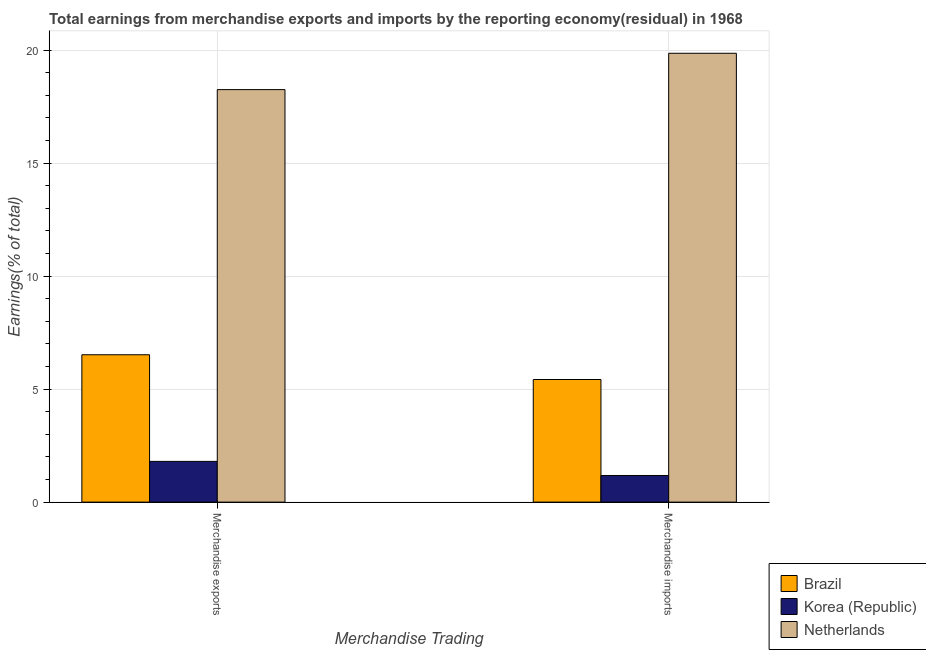Are the number of bars on each tick of the X-axis equal?
Provide a succinct answer. Yes. How many bars are there on the 2nd tick from the left?
Provide a short and direct response. 3. How many bars are there on the 1st tick from the right?
Keep it short and to the point. 3. What is the earnings from merchandise exports in Brazil?
Give a very brief answer. 6.52. Across all countries, what is the maximum earnings from merchandise imports?
Make the answer very short. 19.86. Across all countries, what is the minimum earnings from merchandise imports?
Provide a short and direct response. 1.18. In which country was the earnings from merchandise exports maximum?
Your answer should be compact. Netherlands. In which country was the earnings from merchandise exports minimum?
Give a very brief answer. Korea (Republic). What is the total earnings from merchandise exports in the graph?
Give a very brief answer. 26.58. What is the difference between the earnings from merchandise exports in Korea (Republic) and that in Brazil?
Your response must be concise. -4.72. What is the difference between the earnings from merchandise imports in Netherlands and the earnings from merchandise exports in Korea (Republic)?
Keep it short and to the point. 18.06. What is the average earnings from merchandise imports per country?
Keep it short and to the point. 8.82. What is the difference between the earnings from merchandise imports and earnings from merchandise exports in Korea (Republic)?
Offer a very short reply. -0.62. In how many countries, is the earnings from merchandise imports greater than 11 %?
Your response must be concise. 1. What is the ratio of the earnings from merchandise exports in Brazil to that in Korea (Republic)?
Keep it short and to the point. 3.62. Is the earnings from merchandise imports in Netherlands less than that in Korea (Republic)?
Provide a succinct answer. No. In how many countries, is the earnings from merchandise exports greater than the average earnings from merchandise exports taken over all countries?
Offer a very short reply. 1. How many bars are there?
Make the answer very short. 6. How many countries are there in the graph?
Give a very brief answer. 3. What is the difference between two consecutive major ticks on the Y-axis?
Offer a terse response. 5. Are the values on the major ticks of Y-axis written in scientific E-notation?
Keep it short and to the point. No. Does the graph contain any zero values?
Ensure brevity in your answer.  No. Where does the legend appear in the graph?
Your answer should be compact. Bottom right. How many legend labels are there?
Provide a short and direct response. 3. How are the legend labels stacked?
Give a very brief answer. Vertical. What is the title of the graph?
Offer a terse response. Total earnings from merchandise exports and imports by the reporting economy(residual) in 1968. Does "Northern Mariana Islands" appear as one of the legend labels in the graph?
Your answer should be very brief. No. What is the label or title of the X-axis?
Provide a succinct answer. Merchandise Trading. What is the label or title of the Y-axis?
Make the answer very short. Earnings(% of total). What is the Earnings(% of total) of Brazil in Merchandise exports?
Offer a terse response. 6.52. What is the Earnings(% of total) in Korea (Republic) in Merchandise exports?
Provide a succinct answer. 1.8. What is the Earnings(% of total) of Netherlands in Merchandise exports?
Provide a succinct answer. 18.25. What is the Earnings(% of total) of Brazil in Merchandise imports?
Make the answer very short. 5.43. What is the Earnings(% of total) of Korea (Republic) in Merchandise imports?
Make the answer very short. 1.18. What is the Earnings(% of total) in Netherlands in Merchandise imports?
Provide a succinct answer. 19.86. Across all Merchandise Trading, what is the maximum Earnings(% of total) in Brazil?
Your response must be concise. 6.52. Across all Merchandise Trading, what is the maximum Earnings(% of total) of Korea (Republic)?
Give a very brief answer. 1.8. Across all Merchandise Trading, what is the maximum Earnings(% of total) of Netherlands?
Give a very brief answer. 19.86. Across all Merchandise Trading, what is the minimum Earnings(% of total) in Brazil?
Offer a terse response. 5.43. Across all Merchandise Trading, what is the minimum Earnings(% of total) of Korea (Republic)?
Your response must be concise. 1.18. Across all Merchandise Trading, what is the minimum Earnings(% of total) of Netherlands?
Provide a short and direct response. 18.25. What is the total Earnings(% of total) in Brazil in the graph?
Provide a succinct answer. 11.95. What is the total Earnings(% of total) of Korea (Republic) in the graph?
Your response must be concise. 2.98. What is the total Earnings(% of total) of Netherlands in the graph?
Your answer should be very brief. 38.12. What is the difference between the Earnings(% of total) in Brazil in Merchandise exports and that in Merchandise imports?
Provide a succinct answer. 1.09. What is the difference between the Earnings(% of total) of Korea (Republic) in Merchandise exports and that in Merchandise imports?
Provide a succinct answer. 0.62. What is the difference between the Earnings(% of total) of Netherlands in Merchandise exports and that in Merchandise imports?
Your answer should be compact. -1.61. What is the difference between the Earnings(% of total) of Brazil in Merchandise exports and the Earnings(% of total) of Korea (Republic) in Merchandise imports?
Keep it short and to the point. 5.34. What is the difference between the Earnings(% of total) in Brazil in Merchandise exports and the Earnings(% of total) in Netherlands in Merchandise imports?
Make the answer very short. -13.34. What is the difference between the Earnings(% of total) of Korea (Republic) in Merchandise exports and the Earnings(% of total) of Netherlands in Merchandise imports?
Provide a short and direct response. -18.06. What is the average Earnings(% of total) in Brazil per Merchandise Trading?
Provide a succinct answer. 5.97. What is the average Earnings(% of total) in Korea (Republic) per Merchandise Trading?
Ensure brevity in your answer.  1.49. What is the average Earnings(% of total) in Netherlands per Merchandise Trading?
Offer a terse response. 19.06. What is the difference between the Earnings(% of total) of Brazil and Earnings(% of total) of Korea (Republic) in Merchandise exports?
Your answer should be very brief. 4.72. What is the difference between the Earnings(% of total) in Brazil and Earnings(% of total) in Netherlands in Merchandise exports?
Your response must be concise. -11.73. What is the difference between the Earnings(% of total) of Korea (Republic) and Earnings(% of total) of Netherlands in Merchandise exports?
Your response must be concise. -16.45. What is the difference between the Earnings(% of total) in Brazil and Earnings(% of total) in Korea (Republic) in Merchandise imports?
Provide a short and direct response. 4.25. What is the difference between the Earnings(% of total) in Brazil and Earnings(% of total) in Netherlands in Merchandise imports?
Your answer should be very brief. -14.44. What is the difference between the Earnings(% of total) in Korea (Republic) and Earnings(% of total) in Netherlands in Merchandise imports?
Offer a terse response. -18.68. What is the ratio of the Earnings(% of total) of Brazil in Merchandise exports to that in Merchandise imports?
Offer a terse response. 1.2. What is the ratio of the Earnings(% of total) of Korea (Republic) in Merchandise exports to that in Merchandise imports?
Keep it short and to the point. 1.53. What is the ratio of the Earnings(% of total) of Netherlands in Merchandise exports to that in Merchandise imports?
Offer a very short reply. 0.92. What is the difference between the highest and the second highest Earnings(% of total) of Brazil?
Offer a terse response. 1.09. What is the difference between the highest and the second highest Earnings(% of total) in Korea (Republic)?
Ensure brevity in your answer.  0.62. What is the difference between the highest and the second highest Earnings(% of total) of Netherlands?
Keep it short and to the point. 1.61. What is the difference between the highest and the lowest Earnings(% of total) of Brazil?
Keep it short and to the point. 1.09. What is the difference between the highest and the lowest Earnings(% of total) of Korea (Republic)?
Provide a succinct answer. 0.62. What is the difference between the highest and the lowest Earnings(% of total) in Netherlands?
Offer a very short reply. 1.61. 